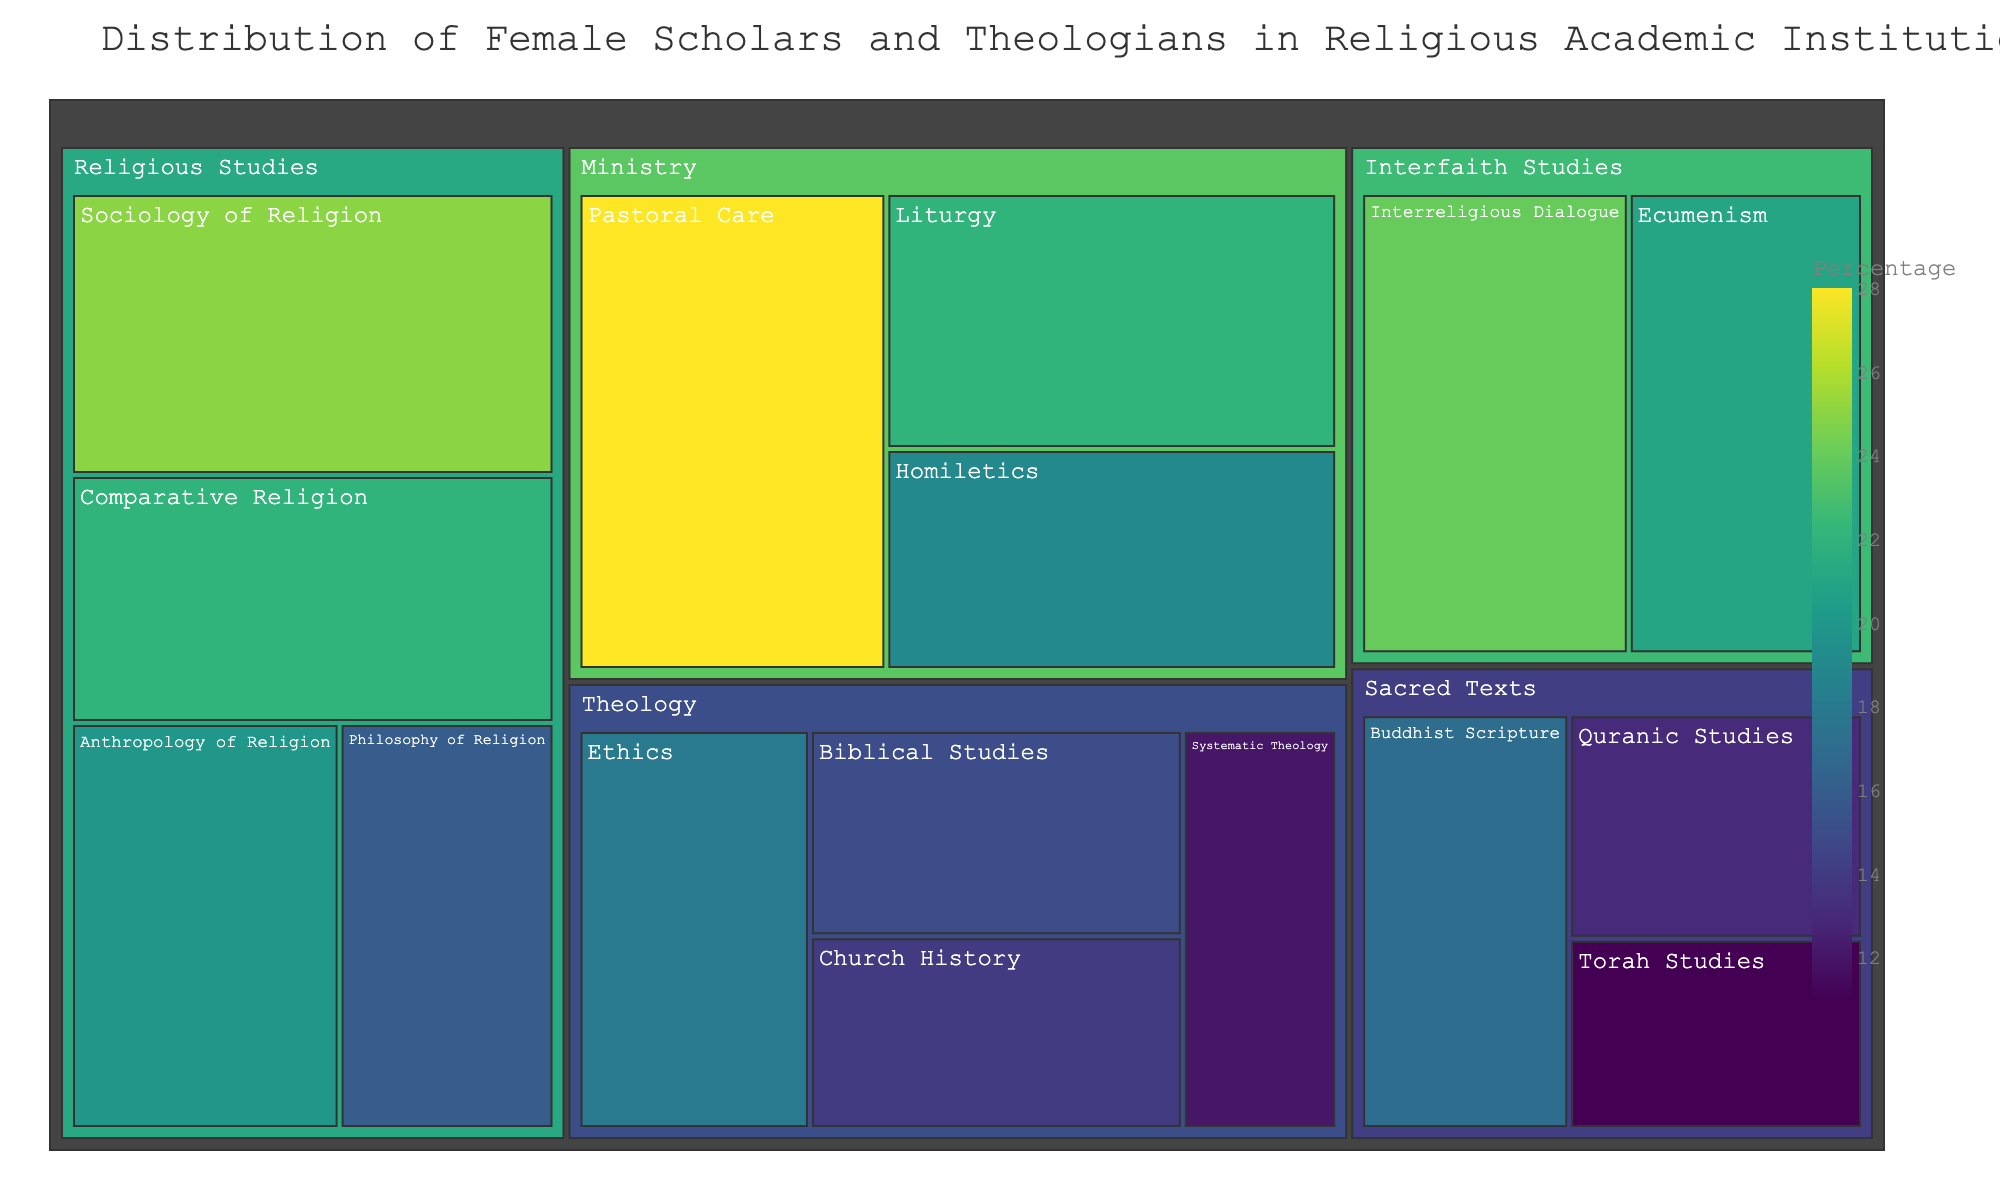What is the title of the figure? The title of the figure is generally located at the top and describes the overall content of the visualization. In this case, it mentions the distribution of female scholars and theologians in religious academic institutions.
Answer: Distribution of Female Scholars and Theologians in Religious Academic Institutions Which subfield has the highest percentage of female scholars? By examining the treemap, look for the subfield block that has the largest value or the darkest color since the color is based on the percentage.
Answer: Pastoral Care What is the percentage of female scholars in Quranic Studies compared to Torah Studies? To answer this, locate both Quranic Studies and Torah Studies in the Sacred Texts category and compare their percentages. Remember to differentiate their respective values from the figure.
Answer: Quranic Studies: 13%, Torah Studies: 11% Which field of study contains the subfield with the highest percentage of female scholars? First, identify the subfield with the highest percentage, then observe which main field category this subfield falls under.
Answer: Ministry Add the percentages of female scholars in Homiletics and Liturgy. What is the sum? Locate the percentages for Homiletics and Liturgy within the Ministry category. Then, sum these percentages to get the total. Homiletics (19%) + Liturgy (22%) = 41%.
Answer: 41% How does the average percentage of female scholars in the Theology subfields compare to the average in the Religious Studies subfields? Calculate the average percentage for each category by adding the percentages of all subfields within Theology and Religious Studies and dividing by the number of subfields in each category. Theology: (15+12+18+14)/4 = 59/4 = 14.75. Religious Studies: (22+25+20+16)/4 = 83/4 = 20.75. Then compare the averages.
Answer: Theology: 14.75%, Religious Studies: 20.75% Which subfield within Interfaith Studies has a higher percentage of female scholars, Ecumenism or Interreligious Dialogue? Compare the two subfields' percentages located under Interfaith Studies. Ecumenism and Interreligious Dialogue have their respective values illustrated within their block sizes and colors.
Answer: Interreligious Dialogue Is the percentage of female scholars higher in Systematic Theology or Buddhist Scripture? Compare the percentages for the respective subfields in their categories. Systematic Theology is within Theology, and Buddhist Scripture is within Sacred Texts.
Answer: Buddhist Scripture Which category has the largest disparity in female scholar percentages among its subfields? To determine the disparity, compare the difference between the highest and lowest values within each field category. Identify the field with the widest range in subfield percentages.
Answer: Religious Studies What is the total percentage of female scholars across all subfields? Add all the percentages of female scholars in each subfield from the entire treemap, providing a total sum. Sum = (15+12+18+14+22+25+20+16+28+19+22+21+24+13+11+17) = 297%.
Answer: 297% 